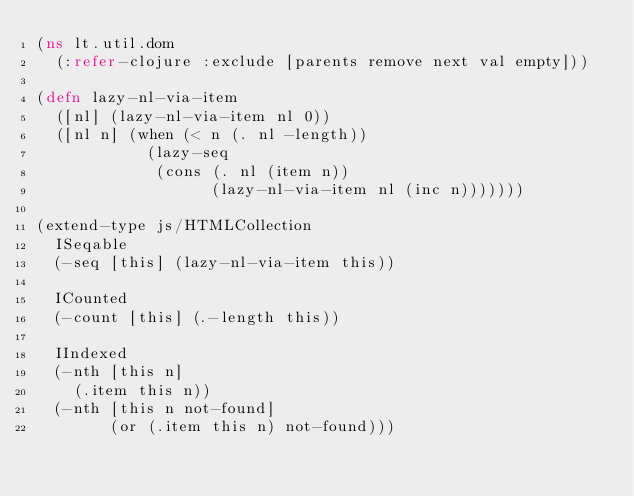Convert code to text. <code><loc_0><loc_0><loc_500><loc_500><_Clojure_>(ns lt.util.dom
  (:refer-clojure :exclude [parents remove next val empty]))

(defn lazy-nl-via-item
  ([nl] (lazy-nl-via-item nl 0))
  ([nl n] (when (< n (. nl -length))
            (lazy-seq
             (cons (. nl (item n))
                   (lazy-nl-via-item nl (inc n)))))))

(extend-type js/HTMLCollection
  ISeqable
  (-seq [this] (lazy-nl-via-item this))

  ICounted
  (-count [this] (.-length this))

  IIndexed
  (-nth [this n]
    (.item this n))
  (-nth [this n not-found]
        (or (.item this n) not-found)))
</code> 